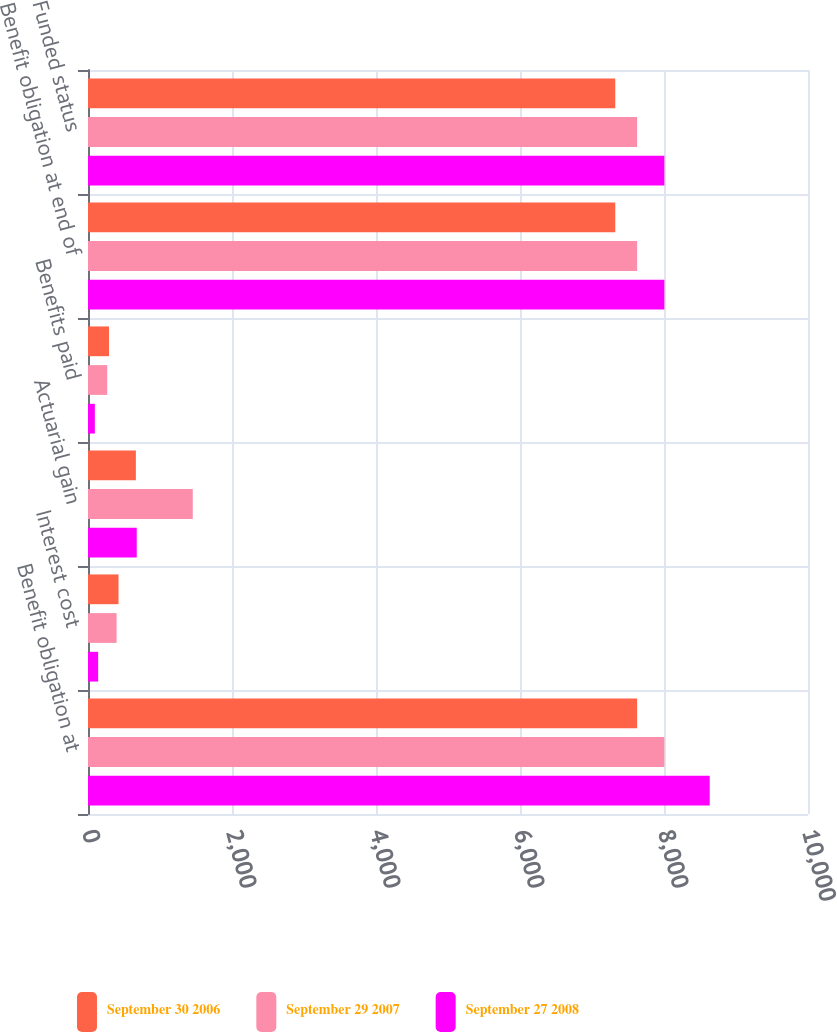<chart> <loc_0><loc_0><loc_500><loc_500><stacked_bar_chart><ecel><fcel>Benefit obligation at<fcel>Interest cost<fcel>Actuarial gain<fcel>Benefits paid<fcel>Benefit obligation at end of<fcel>Funded status<nl><fcel>September 30 2006<fcel>7627<fcel>424<fcel>665<fcel>292<fcel>7323<fcel>7323<nl><fcel>September 29 2007<fcel>8005<fcel>397<fcel>1455<fcel>267<fcel>7627<fcel>7627<nl><fcel>September 27 2008<fcel>8635<fcel>141<fcel>677<fcel>95<fcel>8005<fcel>8005<nl></chart> 